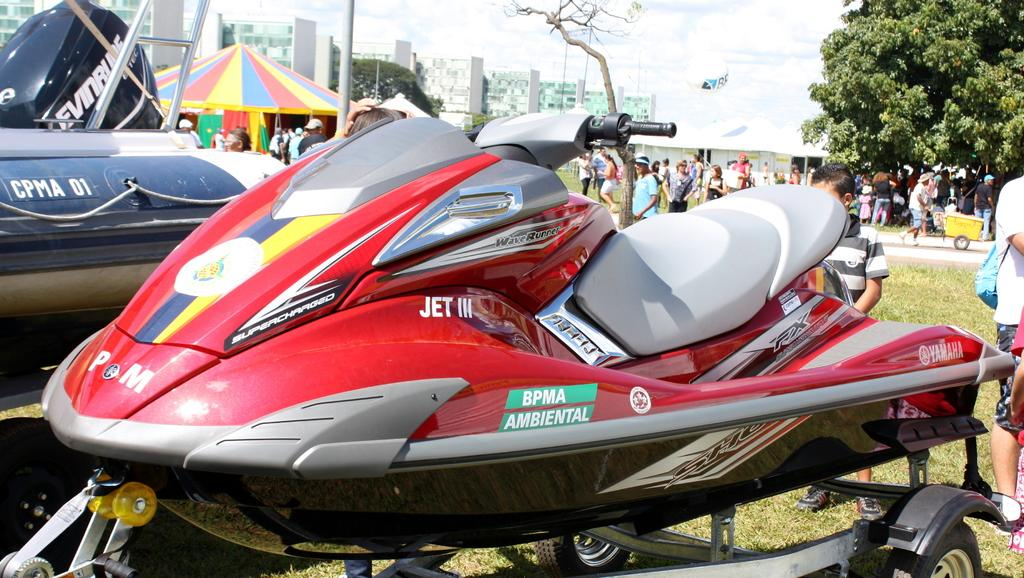What can be seen on the vehicles in the image? There are vehicles with writing on them in the image. What is visible in the background of the image? There are many people in the background of the image. What type of shelter is present in the image? There is a tent in the image. What type of structures can be seen in the image? There are buildings in the image. What type of vegetation is present in the image? There are trees in the image. What type of ground cover is present in the image? There is grass on the ground in the image. How many dolls are sitting on the grass in the image? There are no dolls present in the image; it features vehicles with writing, people, a tent, buildings, trees, and grass. Can you see any cats playing with the grass in the image? There are no cats present in the image; it features vehicles with writing, people, a tent, buildings, trees, and grass. 